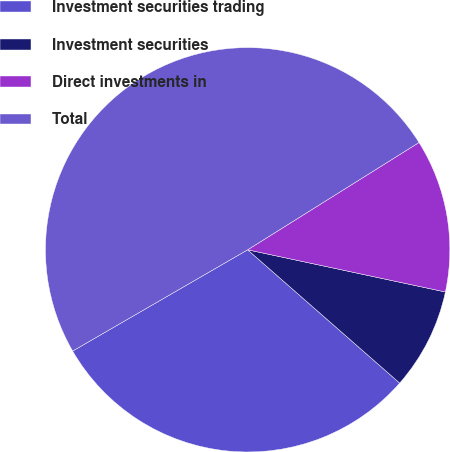Convert chart to OTSL. <chart><loc_0><loc_0><loc_500><loc_500><pie_chart><fcel>Investment securities trading<fcel>Investment securities<fcel>Direct investments in<fcel>Total<nl><fcel>30.2%<fcel>8.11%<fcel>12.25%<fcel>49.45%<nl></chart> 